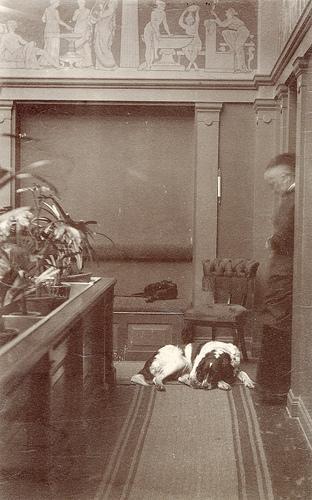How many dogs are visible?
Give a very brief answer. 1. How many potted plants are there?
Give a very brief answer. 2. How many chairs are in the picture?
Give a very brief answer. 2. 